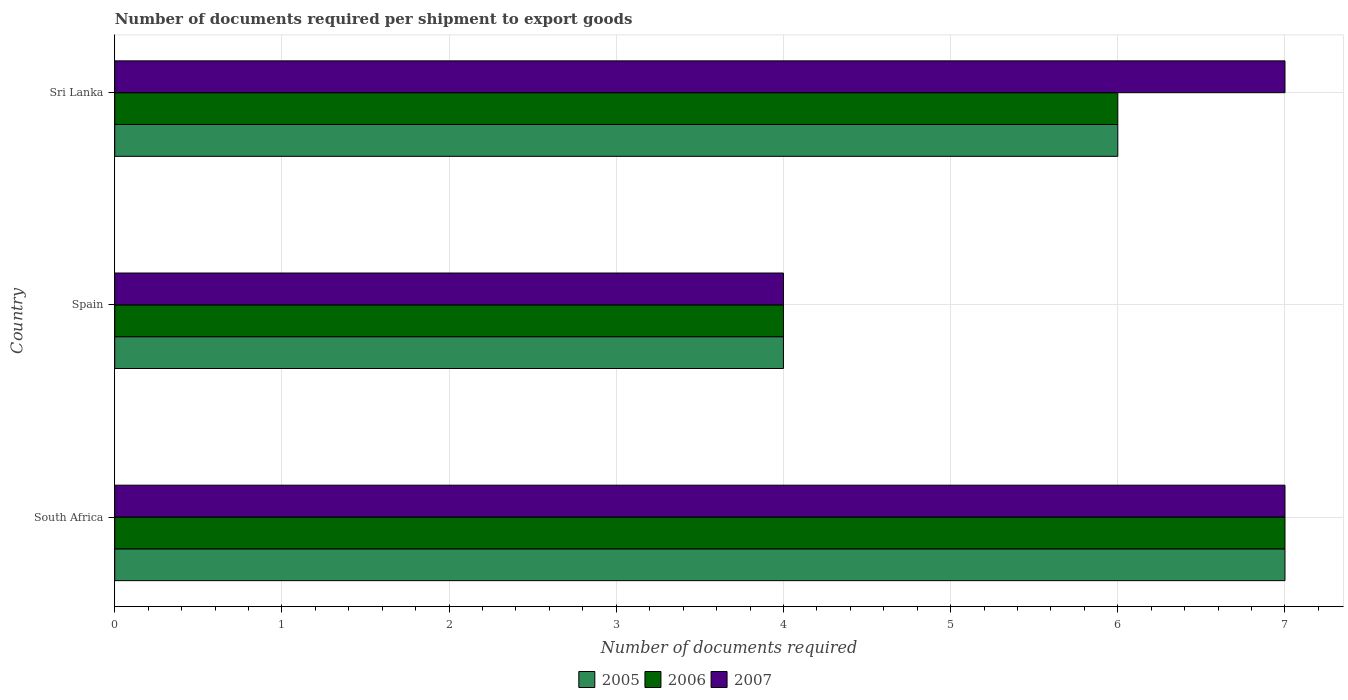How many different coloured bars are there?
Ensure brevity in your answer.  3. Are the number of bars on each tick of the Y-axis equal?
Your answer should be compact. Yes. How many bars are there on the 3rd tick from the bottom?
Your response must be concise. 3. What is the label of the 3rd group of bars from the top?
Your response must be concise. South Africa. In how many cases, is the number of bars for a given country not equal to the number of legend labels?
Offer a terse response. 0. What is the number of documents required per shipment to export goods in 2007 in South Africa?
Your answer should be compact. 7. Across all countries, what is the maximum number of documents required per shipment to export goods in 2006?
Your answer should be compact. 7. In which country was the number of documents required per shipment to export goods in 2005 maximum?
Your answer should be compact. South Africa. In which country was the number of documents required per shipment to export goods in 2006 minimum?
Ensure brevity in your answer.  Spain. What is the average number of documents required per shipment to export goods in 2005 per country?
Provide a succinct answer. 5.67. What is the ratio of the number of documents required per shipment to export goods in 2006 in South Africa to that in Sri Lanka?
Your response must be concise. 1.17. Is the number of documents required per shipment to export goods in 2005 in South Africa less than that in Sri Lanka?
Make the answer very short. No. Is the difference between the number of documents required per shipment to export goods in 2005 in South Africa and Spain greater than the difference between the number of documents required per shipment to export goods in 2006 in South Africa and Spain?
Offer a very short reply. No. What is the difference between the highest and the second highest number of documents required per shipment to export goods in 2006?
Offer a very short reply. 1. In how many countries, is the number of documents required per shipment to export goods in 2005 greater than the average number of documents required per shipment to export goods in 2005 taken over all countries?
Your answer should be very brief. 2. Is the sum of the number of documents required per shipment to export goods in 2005 in South Africa and Spain greater than the maximum number of documents required per shipment to export goods in 2006 across all countries?
Provide a short and direct response. Yes. What does the 1st bar from the bottom in South Africa represents?
Offer a very short reply. 2005. Is it the case that in every country, the sum of the number of documents required per shipment to export goods in 2006 and number of documents required per shipment to export goods in 2005 is greater than the number of documents required per shipment to export goods in 2007?
Offer a terse response. Yes. Are the values on the major ticks of X-axis written in scientific E-notation?
Provide a succinct answer. No. Does the graph contain any zero values?
Your answer should be very brief. No. Where does the legend appear in the graph?
Provide a short and direct response. Bottom center. How are the legend labels stacked?
Your answer should be compact. Horizontal. What is the title of the graph?
Your answer should be very brief. Number of documents required per shipment to export goods. Does "2001" appear as one of the legend labels in the graph?
Offer a terse response. No. What is the label or title of the X-axis?
Your answer should be compact. Number of documents required. What is the label or title of the Y-axis?
Make the answer very short. Country. What is the Number of documents required in 2005 in South Africa?
Offer a terse response. 7. What is the Number of documents required of 2006 in South Africa?
Your response must be concise. 7. What is the Number of documents required in 2007 in South Africa?
Keep it short and to the point. 7. What is the Number of documents required of 2005 in Spain?
Keep it short and to the point. 4. What is the Number of documents required in 2006 in Spain?
Ensure brevity in your answer.  4. What is the Number of documents required of 2007 in Spain?
Offer a terse response. 4. What is the Number of documents required of 2007 in Sri Lanka?
Ensure brevity in your answer.  7. Across all countries, what is the maximum Number of documents required in 2005?
Give a very brief answer. 7. What is the total Number of documents required of 2006 in the graph?
Offer a terse response. 17. What is the difference between the Number of documents required of 2007 in South Africa and that in Spain?
Provide a short and direct response. 3. What is the difference between the Number of documents required in 2007 in South Africa and that in Sri Lanka?
Make the answer very short. 0. What is the difference between the Number of documents required in 2005 in Spain and that in Sri Lanka?
Your answer should be compact. -2. What is the difference between the Number of documents required of 2006 in Spain and that in Sri Lanka?
Your answer should be very brief. -2. What is the difference between the Number of documents required of 2007 in Spain and that in Sri Lanka?
Provide a short and direct response. -3. What is the difference between the Number of documents required of 2005 in South Africa and the Number of documents required of 2006 in Spain?
Provide a succinct answer. 3. What is the difference between the Number of documents required of 2005 in South Africa and the Number of documents required of 2007 in Spain?
Offer a terse response. 3. What is the difference between the Number of documents required of 2005 in South Africa and the Number of documents required of 2006 in Sri Lanka?
Offer a very short reply. 1. What is the difference between the Number of documents required in 2005 in South Africa and the Number of documents required in 2007 in Sri Lanka?
Your response must be concise. 0. What is the average Number of documents required of 2005 per country?
Provide a short and direct response. 5.67. What is the average Number of documents required in 2006 per country?
Your answer should be compact. 5.67. What is the difference between the Number of documents required of 2006 and Number of documents required of 2007 in South Africa?
Your answer should be very brief. 0. What is the difference between the Number of documents required of 2006 and Number of documents required of 2007 in Spain?
Your response must be concise. 0. What is the ratio of the Number of documents required in 2006 in South Africa to that in Spain?
Provide a short and direct response. 1.75. What is the ratio of the Number of documents required in 2005 in South Africa to that in Sri Lanka?
Provide a succinct answer. 1.17. What is the ratio of the Number of documents required in 2005 in Spain to that in Sri Lanka?
Your response must be concise. 0.67. What is the difference between the highest and the second highest Number of documents required of 2005?
Make the answer very short. 1. What is the difference between the highest and the second highest Number of documents required of 2006?
Offer a very short reply. 1. What is the difference between the highest and the lowest Number of documents required in 2005?
Offer a very short reply. 3. What is the difference between the highest and the lowest Number of documents required in 2006?
Your response must be concise. 3. 